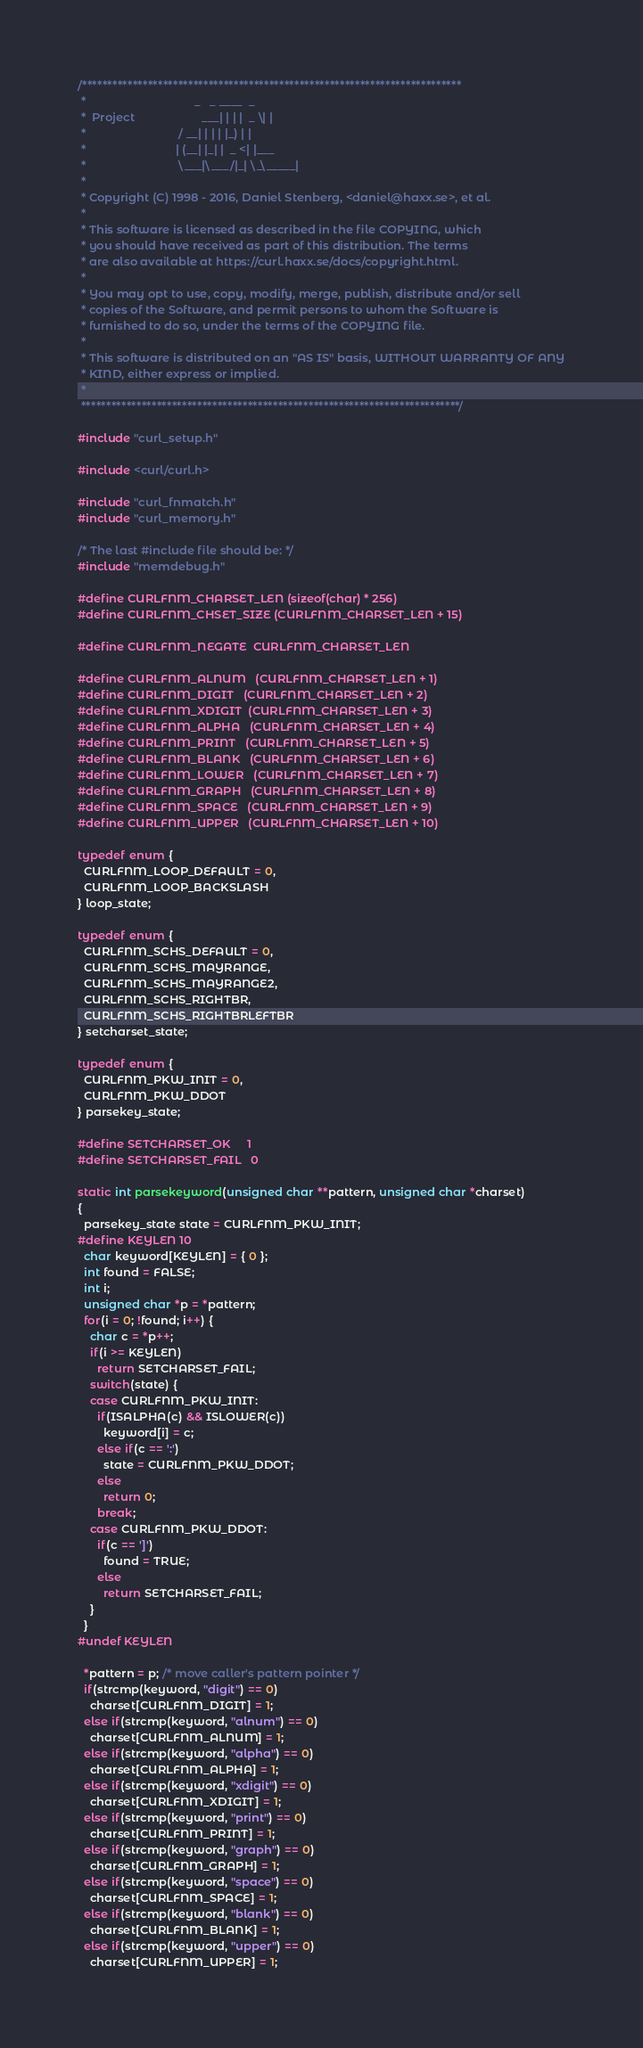<code> <loc_0><loc_0><loc_500><loc_500><_C_>/***************************************************************************
 *                                  _   _ ____  _
 *  Project                     ___| | | |  _ \| |
 *                             / __| | | | |_) | |
 *                            | (__| |_| |  _ <| |___
 *                             \___|\___/|_| \_\_____|
 *
 * Copyright (C) 1998 - 2016, Daniel Stenberg, <daniel@haxx.se>, et al.
 *
 * This software is licensed as described in the file COPYING, which
 * you should have received as part of this distribution. The terms
 * are also available at https://curl.haxx.se/docs/copyright.html.
 *
 * You may opt to use, copy, modify, merge, publish, distribute and/or sell
 * copies of the Software, and permit persons to whom the Software is
 * furnished to do so, under the terms of the COPYING file.
 *
 * This software is distributed on an "AS IS" basis, WITHOUT WARRANTY OF ANY
 * KIND, either express or implied.
 *
 ***************************************************************************/

#include "curl_setup.h"

#include <curl/curl.h>

#include "curl_fnmatch.h"
#include "curl_memory.h"

/* The last #include file should be: */
#include "memdebug.h"

#define CURLFNM_CHARSET_LEN (sizeof(char) * 256)
#define CURLFNM_CHSET_SIZE (CURLFNM_CHARSET_LEN + 15)

#define CURLFNM_NEGATE  CURLFNM_CHARSET_LEN

#define CURLFNM_ALNUM   (CURLFNM_CHARSET_LEN + 1)
#define CURLFNM_DIGIT   (CURLFNM_CHARSET_LEN + 2)
#define CURLFNM_XDIGIT  (CURLFNM_CHARSET_LEN + 3)
#define CURLFNM_ALPHA   (CURLFNM_CHARSET_LEN + 4)
#define CURLFNM_PRINT   (CURLFNM_CHARSET_LEN + 5)
#define CURLFNM_BLANK   (CURLFNM_CHARSET_LEN + 6)
#define CURLFNM_LOWER   (CURLFNM_CHARSET_LEN + 7)
#define CURLFNM_GRAPH   (CURLFNM_CHARSET_LEN + 8)
#define CURLFNM_SPACE   (CURLFNM_CHARSET_LEN + 9)
#define CURLFNM_UPPER   (CURLFNM_CHARSET_LEN + 10)

typedef enum {
  CURLFNM_LOOP_DEFAULT = 0,
  CURLFNM_LOOP_BACKSLASH
} loop_state;

typedef enum {
  CURLFNM_SCHS_DEFAULT = 0,
  CURLFNM_SCHS_MAYRANGE,
  CURLFNM_SCHS_MAYRANGE2,
  CURLFNM_SCHS_RIGHTBR,
  CURLFNM_SCHS_RIGHTBRLEFTBR
} setcharset_state;

typedef enum {
  CURLFNM_PKW_INIT = 0,
  CURLFNM_PKW_DDOT
} parsekey_state;

#define SETCHARSET_OK     1
#define SETCHARSET_FAIL   0

static int parsekeyword(unsigned char **pattern, unsigned char *charset)
{
  parsekey_state state = CURLFNM_PKW_INIT;
#define KEYLEN 10
  char keyword[KEYLEN] = { 0 };
  int found = FALSE;
  int i;
  unsigned char *p = *pattern;
  for(i = 0; !found; i++) {
    char c = *p++;
    if(i >= KEYLEN)
      return SETCHARSET_FAIL;
    switch(state) {
    case CURLFNM_PKW_INIT:
      if(ISALPHA(c) && ISLOWER(c))
        keyword[i] = c;
      else if(c == ':')
        state = CURLFNM_PKW_DDOT;
      else
        return 0;
      break;
    case CURLFNM_PKW_DDOT:
      if(c == ']')
        found = TRUE;
      else
        return SETCHARSET_FAIL;
    }
  }
#undef KEYLEN

  *pattern = p; /* move caller's pattern pointer */
  if(strcmp(keyword, "digit") == 0)
    charset[CURLFNM_DIGIT] = 1;
  else if(strcmp(keyword, "alnum") == 0)
    charset[CURLFNM_ALNUM] = 1;
  else if(strcmp(keyword, "alpha") == 0)
    charset[CURLFNM_ALPHA] = 1;
  else if(strcmp(keyword, "xdigit") == 0)
    charset[CURLFNM_XDIGIT] = 1;
  else if(strcmp(keyword, "print") == 0)
    charset[CURLFNM_PRINT] = 1;
  else if(strcmp(keyword, "graph") == 0)
    charset[CURLFNM_GRAPH] = 1;
  else if(strcmp(keyword, "space") == 0)
    charset[CURLFNM_SPACE] = 1;
  else if(strcmp(keyword, "blank") == 0)
    charset[CURLFNM_BLANK] = 1;
  else if(strcmp(keyword, "upper") == 0)
    charset[CURLFNM_UPPER] = 1;</code> 